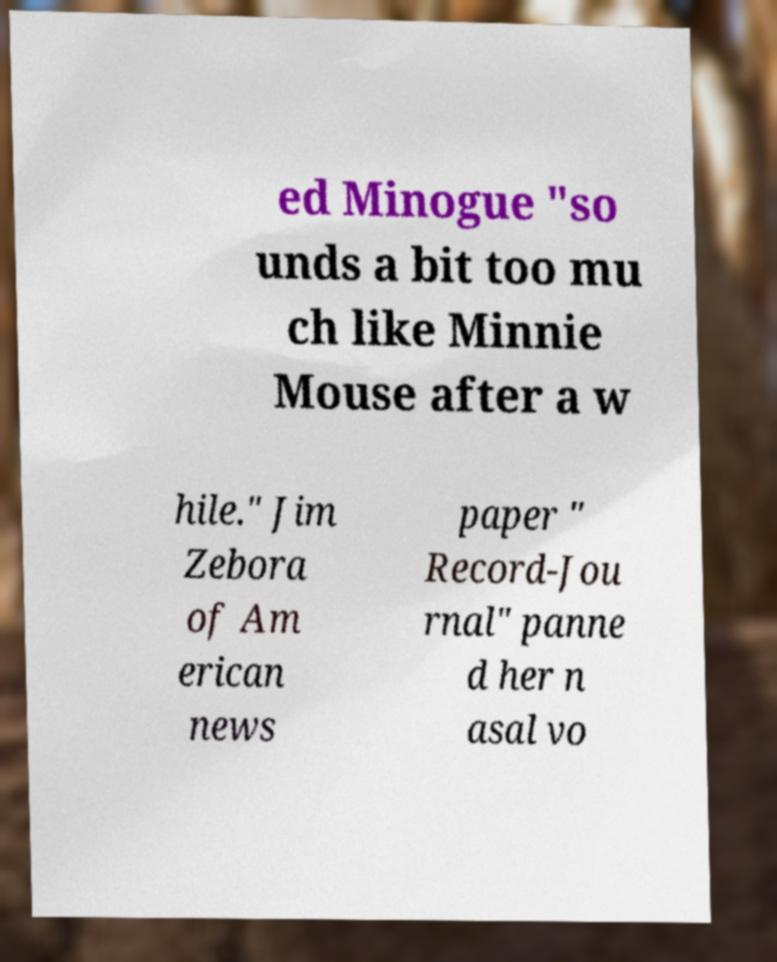Could you extract and type out the text from this image? ed Minogue "so unds a bit too mu ch like Minnie Mouse after a w hile." Jim Zebora of Am erican news paper " Record-Jou rnal" panne d her n asal vo 